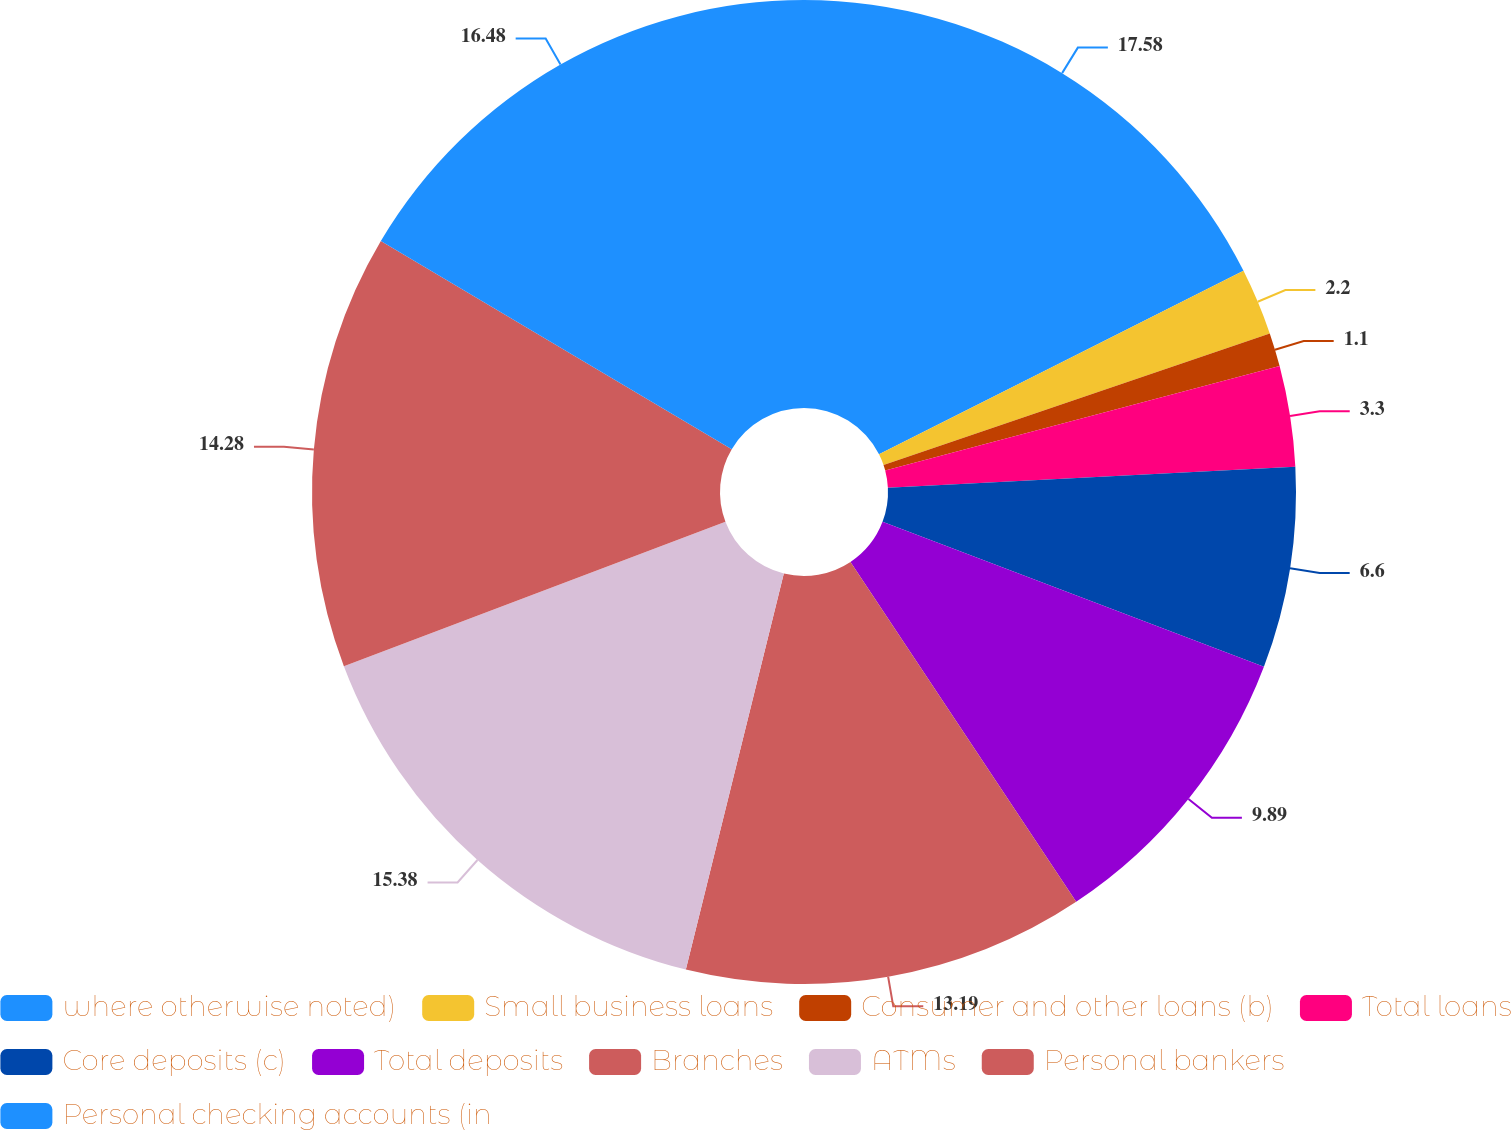Convert chart to OTSL. <chart><loc_0><loc_0><loc_500><loc_500><pie_chart><fcel>where otherwise noted)<fcel>Small business loans<fcel>Consumer and other loans (b)<fcel>Total loans<fcel>Core deposits (c)<fcel>Total deposits<fcel>Branches<fcel>ATMs<fcel>Personal bankers<fcel>Personal checking accounts (in<nl><fcel>17.58%<fcel>2.2%<fcel>1.1%<fcel>3.3%<fcel>6.6%<fcel>9.89%<fcel>13.19%<fcel>15.38%<fcel>14.28%<fcel>16.48%<nl></chart> 